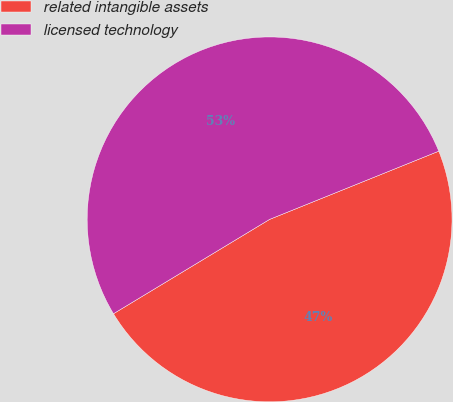<chart> <loc_0><loc_0><loc_500><loc_500><pie_chart><fcel>related intangible assets<fcel>licensed technology<nl><fcel>47.45%<fcel>52.55%<nl></chart> 